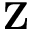<formula> <loc_0><loc_0><loc_500><loc_500>Z</formula> 